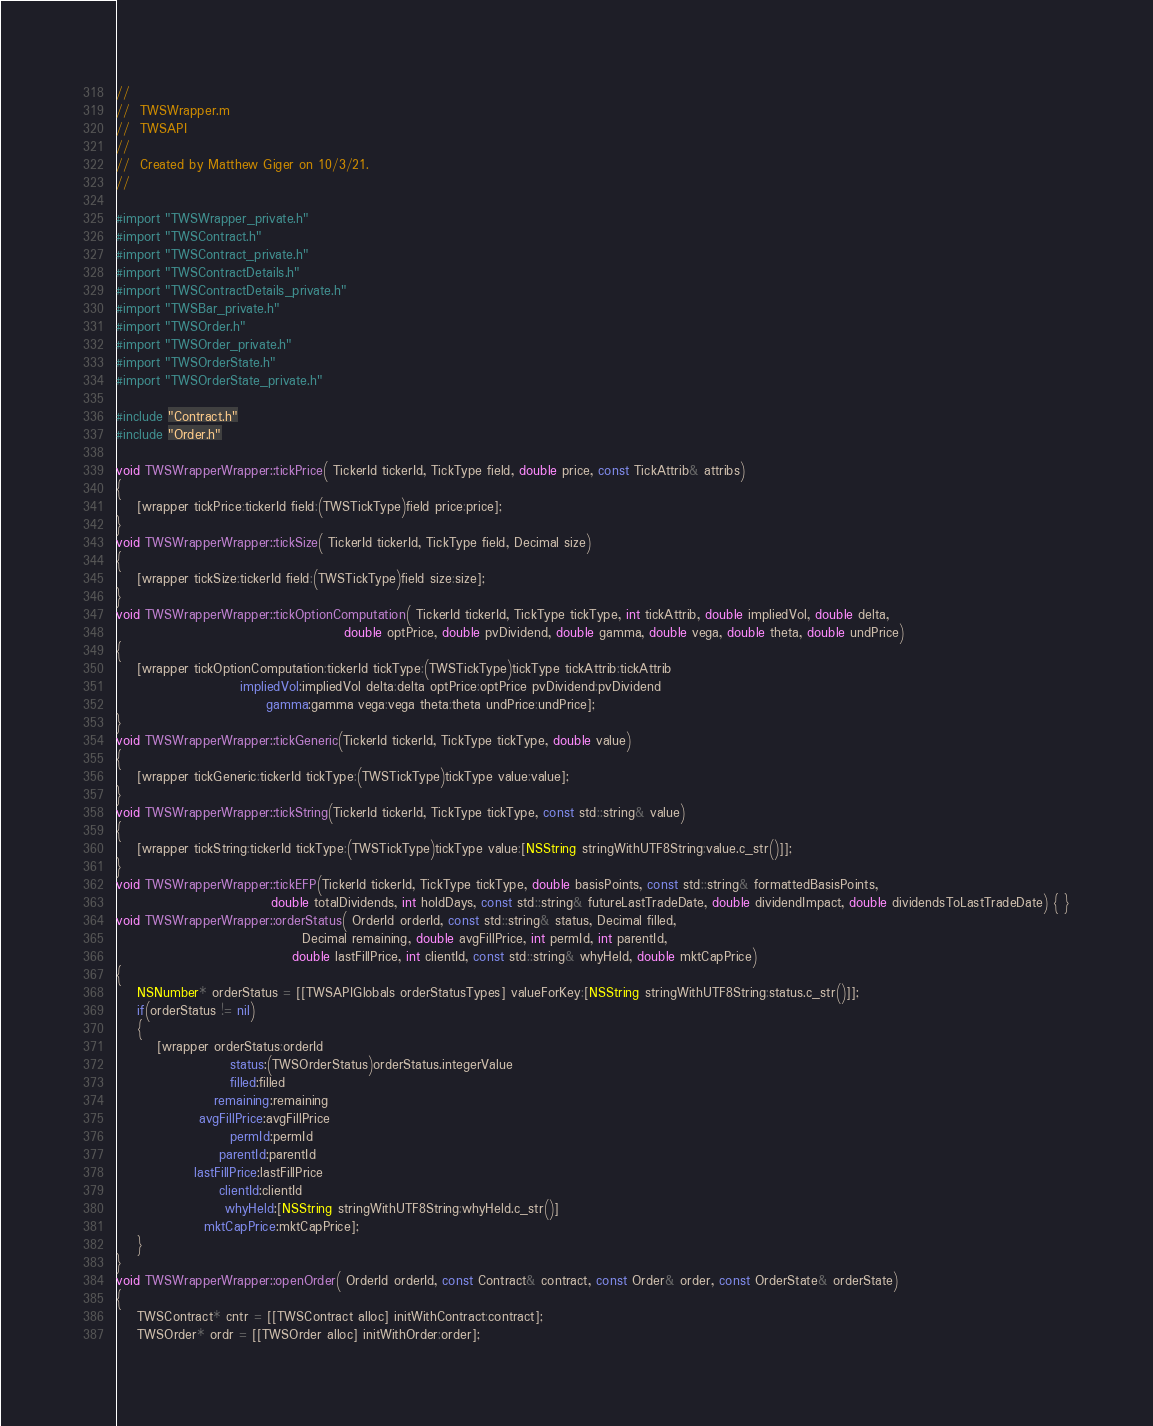<code> <loc_0><loc_0><loc_500><loc_500><_ObjectiveC_>//
//  TWSWrapper.m
//  TWSAPI
//
//  Created by Matthew Giger on 10/3/21.
//

#import "TWSWrapper_private.h"
#import "TWSContract.h"
#import "TWSContract_private.h"
#import "TWSContractDetails.h"
#import "TWSContractDetails_private.h"
#import "TWSBar_private.h"
#import "TWSOrder.h"
#import "TWSOrder_private.h"
#import "TWSOrderState.h"
#import "TWSOrderState_private.h"

#include "Contract.h"
#include "Order.h"

void TWSWrapperWrapper::tickPrice( TickerId tickerId, TickType field, double price, const TickAttrib& attribs)
{
	[wrapper tickPrice:tickerId field:(TWSTickType)field price:price];
}
void TWSWrapperWrapper::tickSize( TickerId tickerId, TickType field, Decimal size)
{
	[wrapper tickSize:tickerId field:(TWSTickType)field size:size];
}
void TWSWrapperWrapper::tickOptionComputation( TickerId tickerId, TickType tickType, int tickAttrib, double impliedVol, double delta,
											double optPrice, double pvDividend, double gamma, double vega, double theta, double undPrice)
{
	[wrapper tickOptionComputation:tickerId tickType:(TWSTickType)tickType tickAttrib:tickAttrib
						impliedVol:impliedVol delta:delta optPrice:optPrice pvDividend:pvDividend
							 gamma:gamma vega:vega theta:theta undPrice:undPrice];
}
void TWSWrapperWrapper::tickGeneric(TickerId tickerId, TickType tickType, double value)
{
	[wrapper tickGeneric:tickerId tickType:(TWSTickType)tickType value:value];
}
void TWSWrapperWrapper::tickString(TickerId tickerId, TickType tickType, const std::string& value)
{
	[wrapper tickString:tickerId tickType:(TWSTickType)tickType value:[NSString stringWithUTF8String:value.c_str()]];
}
void TWSWrapperWrapper::tickEFP(TickerId tickerId, TickType tickType, double basisPoints, const std::string& formattedBasisPoints,
							  double totalDividends, int holdDays, const std::string& futureLastTradeDate, double dividendImpact, double dividendsToLastTradeDate) { }
void TWSWrapperWrapper::orderStatus( OrderId orderId, const std::string& status, Decimal filled,
									Decimal remaining, double avgFillPrice, int permId, int parentId,
								  double lastFillPrice, int clientId, const std::string& whyHeld, double mktCapPrice)
{
	NSNumber* orderStatus = [[TWSAPIGlobals orderStatusTypes] valueForKey:[NSString stringWithUTF8String:status.c_str()]];
	if(orderStatus != nil)
	{
		[wrapper orderStatus:orderId
					  status:(TWSOrderStatus)orderStatus.integerValue
					  filled:filled
				   remaining:remaining
				avgFillPrice:avgFillPrice
					  permId:permId
					parentId:parentId
			   lastFillPrice:lastFillPrice
					clientId:clientId
					 whyHeld:[NSString stringWithUTF8String:whyHeld.c_str()]
				 mktCapPrice:mktCapPrice];
	}
}
void TWSWrapperWrapper::openOrder( OrderId orderId, const Contract& contract, const Order& order, const OrderState& orderState)
{
	TWSContract* cntr = [[TWSContract alloc] initWithContract:contract];
	TWSOrder* ordr = [[TWSOrder alloc] initWithOrder:order];</code> 